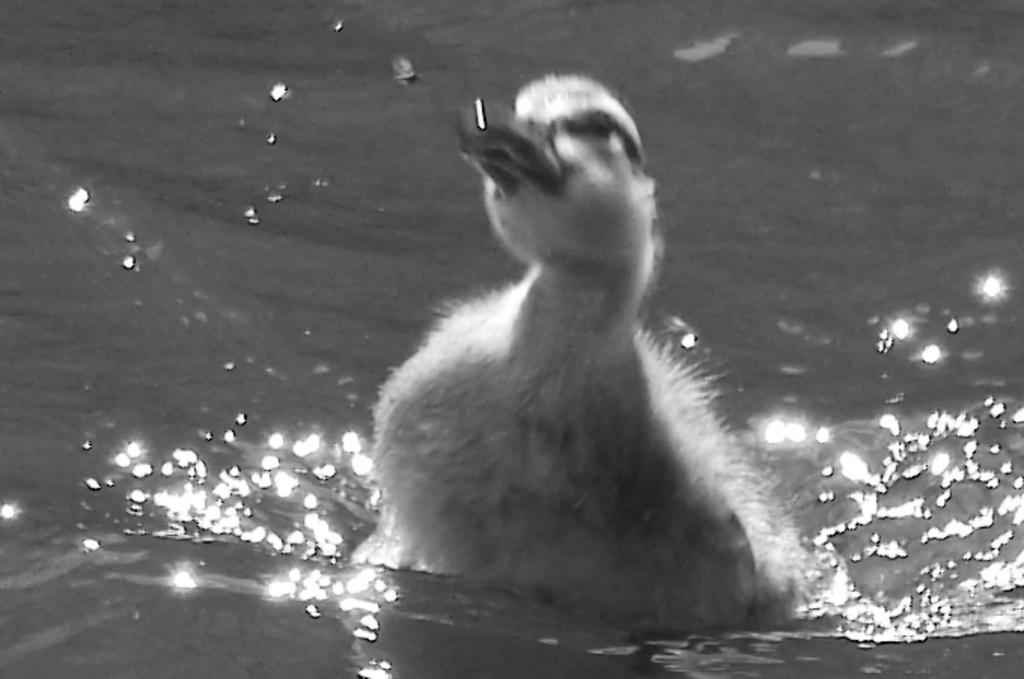What animal is present in the image? There is a duck in the image. Where is the duck located? The duck is in the water. What can be observed about the water's surface in the image? There are ripples in the water. What type of root can be seen growing near the duck in the image? There is no root visible in the image; it features a duck in the water with ripples on the surface. 